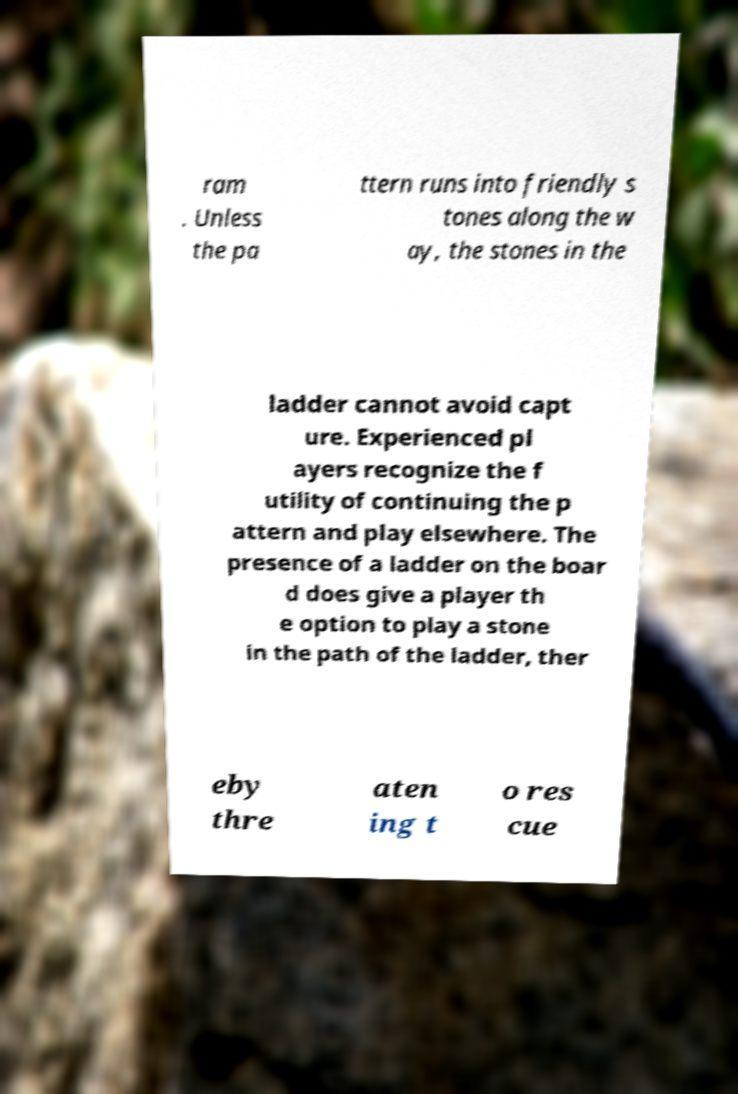Could you extract and type out the text from this image? ram . Unless the pa ttern runs into friendly s tones along the w ay, the stones in the ladder cannot avoid capt ure. Experienced pl ayers recognize the f utility of continuing the p attern and play elsewhere. The presence of a ladder on the boar d does give a player th e option to play a stone in the path of the ladder, ther eby thre aten ing t o res cue 